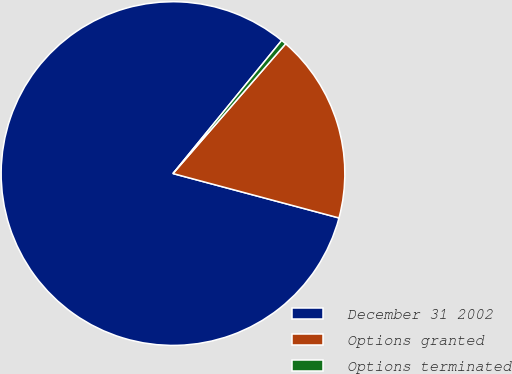Convert chart to OTSL. <chart><loc_0><loc_0><loc_500><loc_500><pie_chart><fcel>December 31 2002<fcel>Options granted<fcel>Options terminated<nl><fcel>81.74%<fcel>17.78%<fcel>0.48%<nl></chart> 